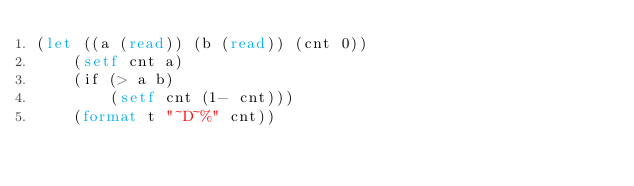Convert code to text. <code><loc_0><loc_0><loc_500><loc_500><_Lisp_>(let ((a (read)) (b (read)) (cnt 0))
    (setf cnt a)
    (if (> a b)
        (setf cnt (1- cnt)))
    (format t "~D~%" cnt))</code> 